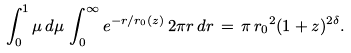<formula> <loc_0><loc_0><loc_500><loc_500>\int _ { 0 } ^ { 1 } \mu \, d \mu \, \int _ { 0 } ^ { \infty } e ^ { - r / r _ { 0 } ( z ) } \, 2 \pi r \, d r \, = \, \pi \, { r _ { 0 } } ^ { 2 } ( 1 + z ) ^ { 2 \delta } .</formula> 